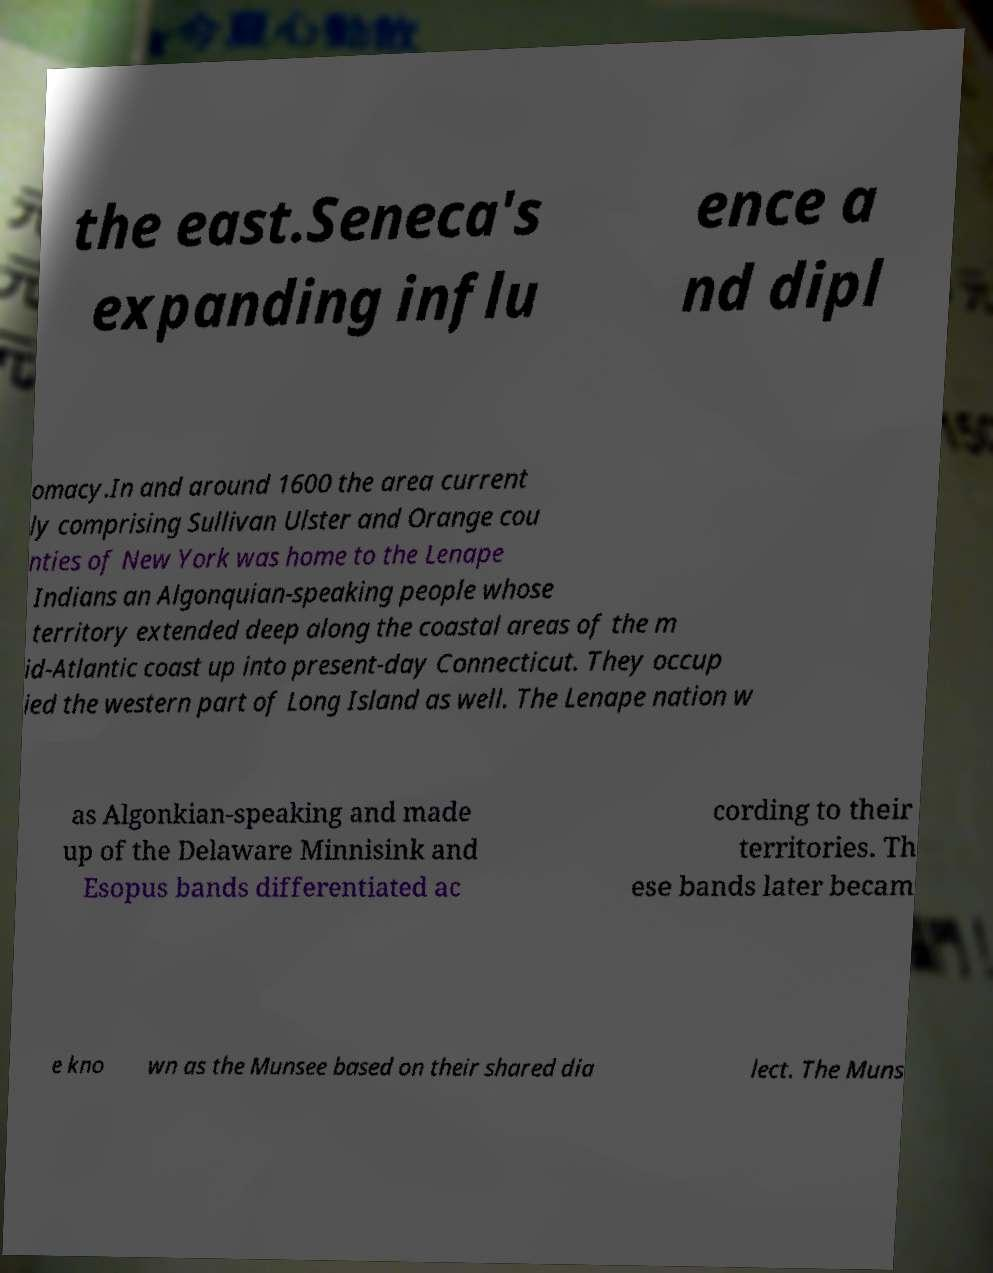Please read and relay the text visible in this image. What does it say? the east.Seneca's expanding influ ence a nd dipl omacy.In and around 1600 the area current ly comprising Sullivan Ulster and Orange cou nties of New York was home to the Lenape Indians an Algonquian-speaking people whose territory extended deep along the coastal areas of the m id-Atlantic coast up into present-day Connecticut. They occup ied the western part of Long Island as well. The Lenape nation w as Algonkian-speaking and made up of the Delaware Minnisink and Esopus bands differentiated ac cording to their territories. Th ese bands later becam e kno wn as the Munsee based on their shared dia lect. The Muns 